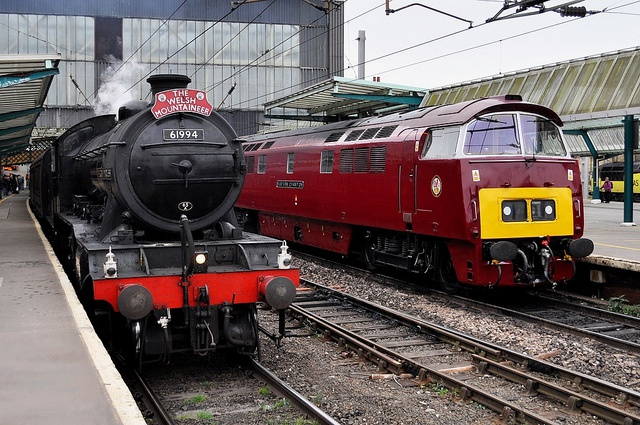Describe the objects in this image and their specific colors. I can see train in gray, maroon, black, and darkgray tones, train in gray, black, red, and darkgray tones, people in gray, black, purple, brown, and maroon tones, people in gray, black, maroon, and darkgray tones, and people in black, maroon, and gray tones in this image. 